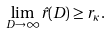Convert formula to latex. <formula><loc_0><loc_0><loc_500><loc_500>\lim _ { D \rightarrow \infty } { \hat { r } } ( D ) \geq r _ { \kappa } .</formula> 